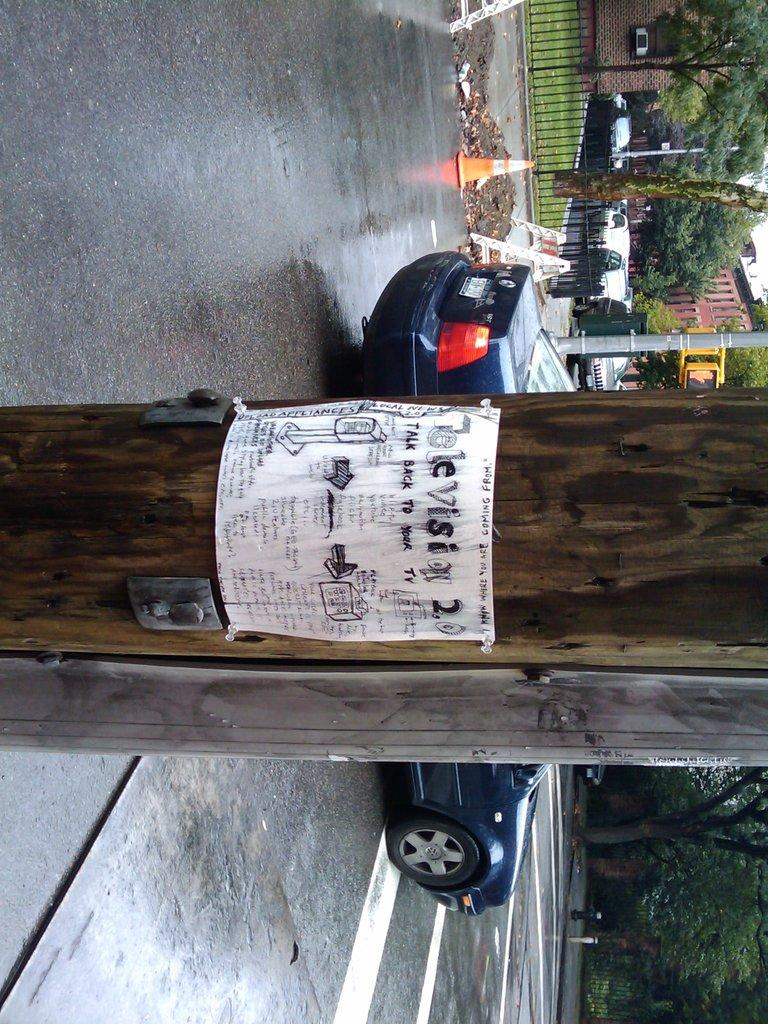What is one of the natural elements present in the image? There is a tree in the image. What is happening on the road in the image? A car is moving on the road in the image. Can you describe the landscape in the image? There are trees visible in the down side of the image. What type of education is being taught to the cat in the image? There is no cat present in the image, and therefore no education is being taught. How many cars are visible in the image? Only one car is visible in the image, as it is moving on the road. 